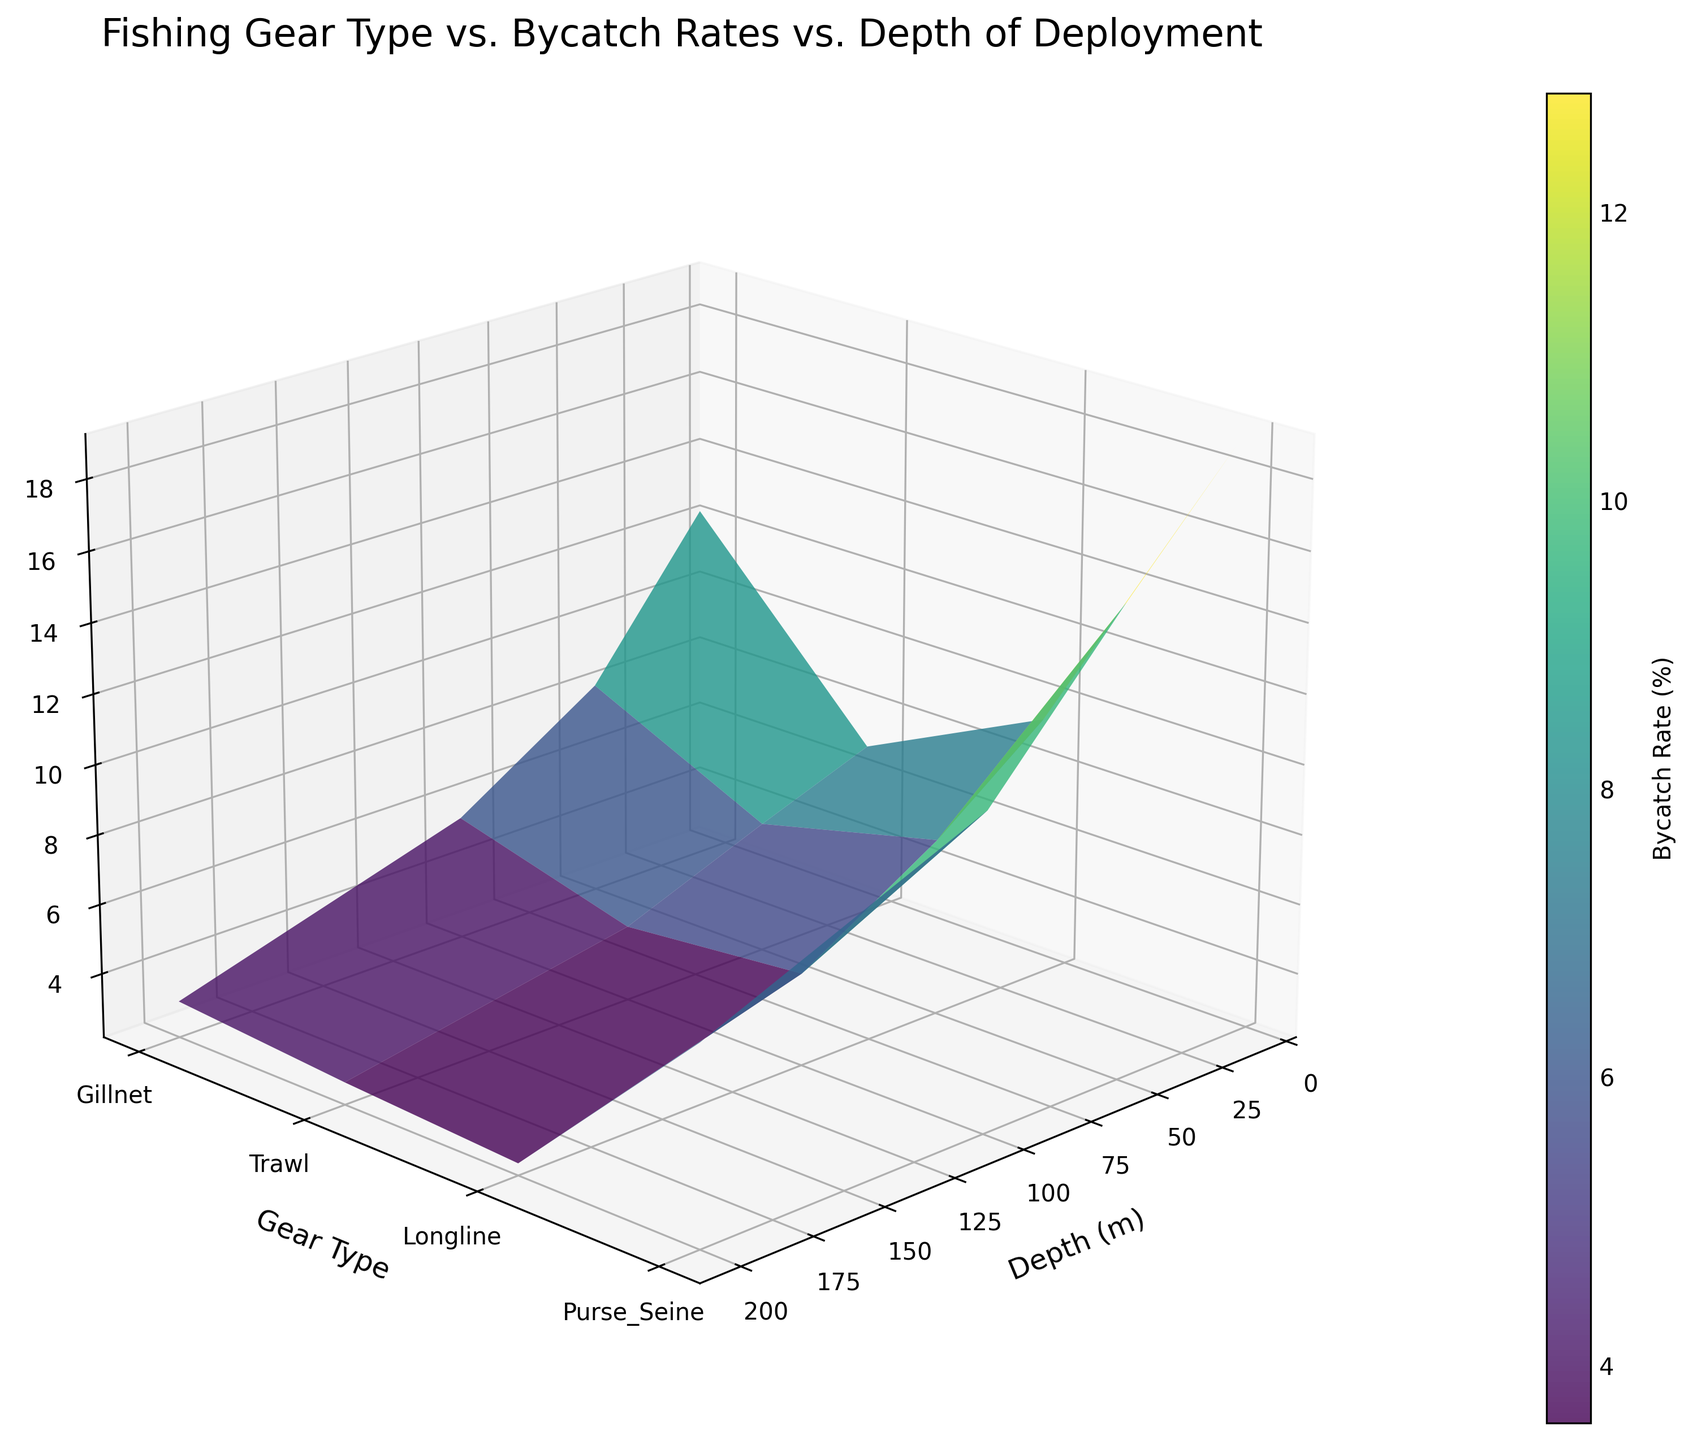What is the title of the figure? The title is usually located at the top of the figure. Look for the largest and boldest text.
Answer: Fishing Gear Type vs. Bycatch Rates vs. Depth of Deployment What is the color of the surface plot? The color of the surface plot corresponds to the colormap applied. Observing the surface plot, the dominant color is visible.
Answer: Viridis (shades of green to purple) What is the gear type with the highest bycatch rate at 10 meters depth? Look at the Z-values at 10 meters depth for all gear types and identify the highest value.
Answer: Trawl At 200 meters depth, which gear type has the lowest bycatch rate? Compare the Z-values at 200 meters depth for all gear types and identify the lowest one.
Answer: Purse_Seine Which axis represents the depth of deployment? Look at the axis labels; the depth of deployment will be labeled either as Depth or similar metric with (m) for meters.
Answer: X-axis How does the bycatch rate for Gillnets change as depth increases from 10 meters to 200 meters? Trace the bycatch rate for Gillnets across increasing depth values and observe the trend. The bycatch rate decreases as the depth increases.
Answer: Decreases Which gear type has the steepest decline in bycatch rate from 10 meters to 200 meters? Compare the changes in bycatch rates from 10 meters to 200 meters for all gear types. Calculate the declines and identify the gear type with the largest decline.
Answer: Trawl What is the bycatch rate for Longline at 100 meters depth? Find the intersection of Longline and 100 meters depth and observe the Z-value (bycatch rate).
Answer: 4.3% Among Gillnet, Trawl, and Longline, which gear type has the most consistent (steady) bycatch rate across different depths? Compare the changes in bycatch rates for each gear type at all depths and identify which has the least variation. Gillnet has a more consistent decline across various depths.
Answer: Gillnet What is the average bycatch rate for Purse_Seine gear across all depths? There are bycatch rates at 10, 50, 100, and 200 meters depths for Purse_Seine. Summing these rates and dividing by the number of depth points provides the average. Calculation: (9.6 + 7.2 + 4.8 + 2.5) / 4.
Answer: 6.025% 